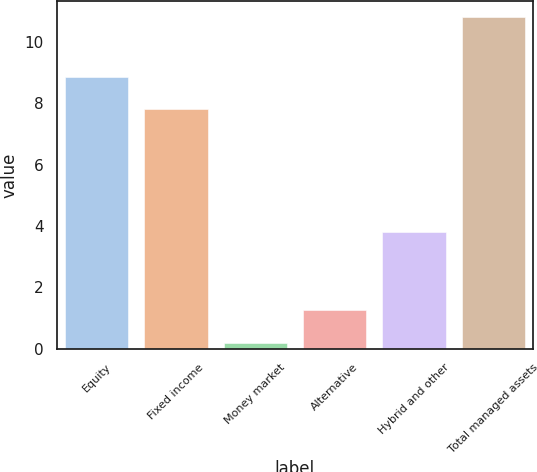Convert chart. <chart><loc_0><loc_0><loc_500><loc_500><bar_chart><fcel>Equity<fcel>Fixed income<fcel>Money market<fcel>Alternative<fcel>Hybrid and other<fcel>Total managed assets<nl><fcel>8.86<fcel>7.8<fcel>0.2<fcel>1.26<fcel>3.8<fcel>10.8<nl></chart> 